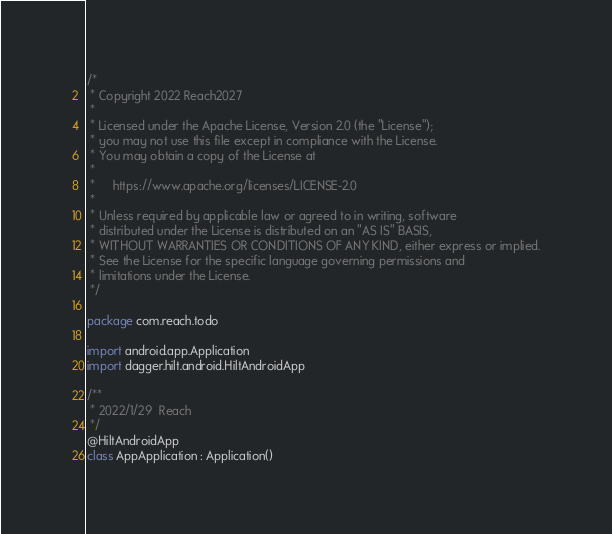<code> <loc_0><loc_0><loc_500><loc_500><_Kotlin_>/*
 * Copyright 2022 Reach2027
 *
 * Licensed under the Apache License, Version 2.0 (the "License");
 * you may not use this file except in compliance with the License.
 * You may obtain a copy of the License at
 *
 *     https://www.apache.org/licenses/LICENSE-2.0
 *
 * Unless required by applicable law or agreed to in writing, software
 * distributed under the License is distributed on an "AS IS" BASIS,
 * WITHOUT WARRANTIES OR CONDITIONS OF ANY KIND, either express or implied.
 * See the License for the specific language governing permissions and
 * limitations under the License.
 */

package com.reach.todo

import android.app.Application
import dagger.hilt.android.HiltAndroidApp

/**
 * 2022/1/29  Reach
 */
@HiltAndroidApp
class AppApplication : Application()
</code> 